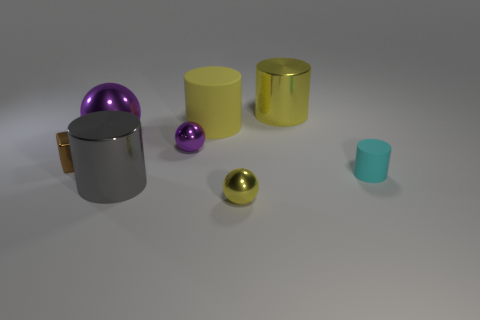The big matte thing that is left of the large yellow metal object that is behind the brown object is what shape?
Offer a very short reply. Cylinder. There is another small object that is the same shape as the gray metal object; what is it made of?
Your answer should be compact. Rubber. There is a matte cylinder that is the same size as the metallic cube; what color is it?
Offer a terse response. Cyan. Is the number of tiny brown metallic cubes that are on the left side of the metal block the same as the number of big green cylinders?
Give a very brief answer. Yes. What color is the metal cylinder that is in front of the big cylinder to the right of the small yellow thing?
Offer a terse response. Gray. There is a yellow shiny thing that is on the left side of the big thing right of the small yellow metal thing; how big is it?
Your answer should be compact. Small. The metal cylinder that is the same color as the big rubber cylinder is what size?
Your answer should be compact. Large. What number of other things are there of the same size as the yellow rubber thing?
Keep it short and to the point. 3. What is the color of the large rubber cylinder to the right of the shiny ball that is left of the purple metal object that is in front of the large purple thing?
Make the answer very short. Yellow. What number of other objects are the same shape as the gray thing?
Ensure brevity in your answer.  3. 